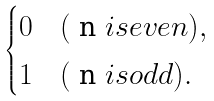<formula> <loc_0><loc_0><loc_500><loc_500>\begin{cases} 0 & ( $ n $ i s e v e n ) , \\ 1 & ( $ n $ i s o d d ) . \end{cases}</formula> 